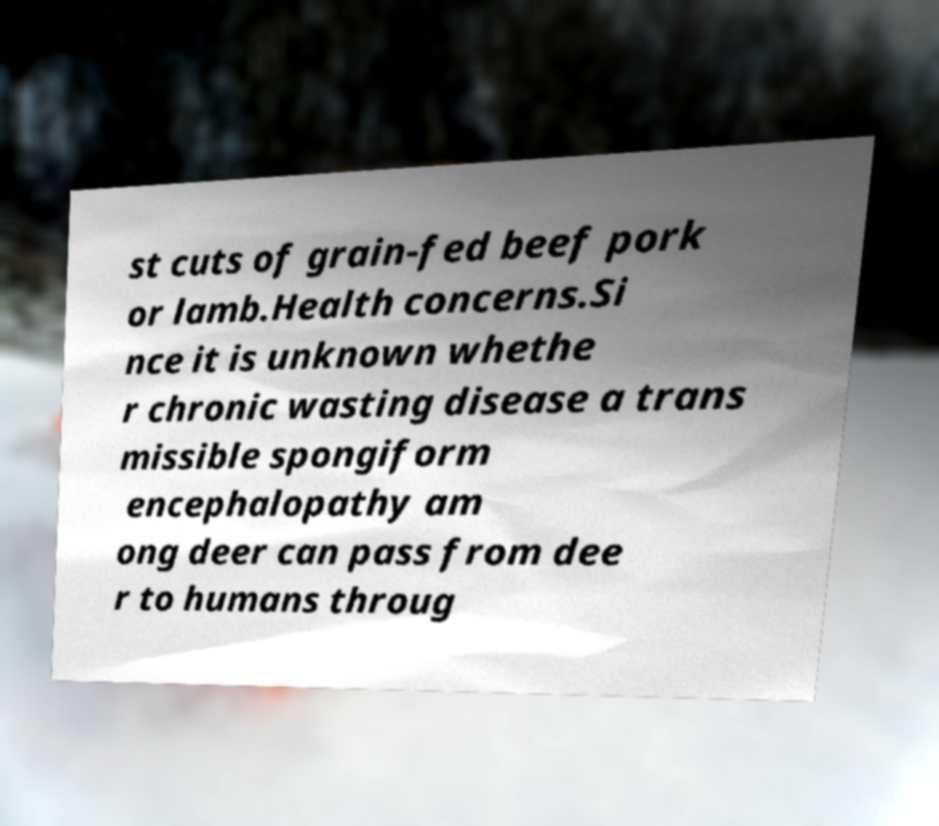Could you extract and type out the text from this image? st cuts of grain-fed beef pork or lamb.Health concerns.Si nce it is unknown whethe r chronic wasting disease a trans missible spongiform encephalopathy am ong deer can pass from dee r to humans throug 